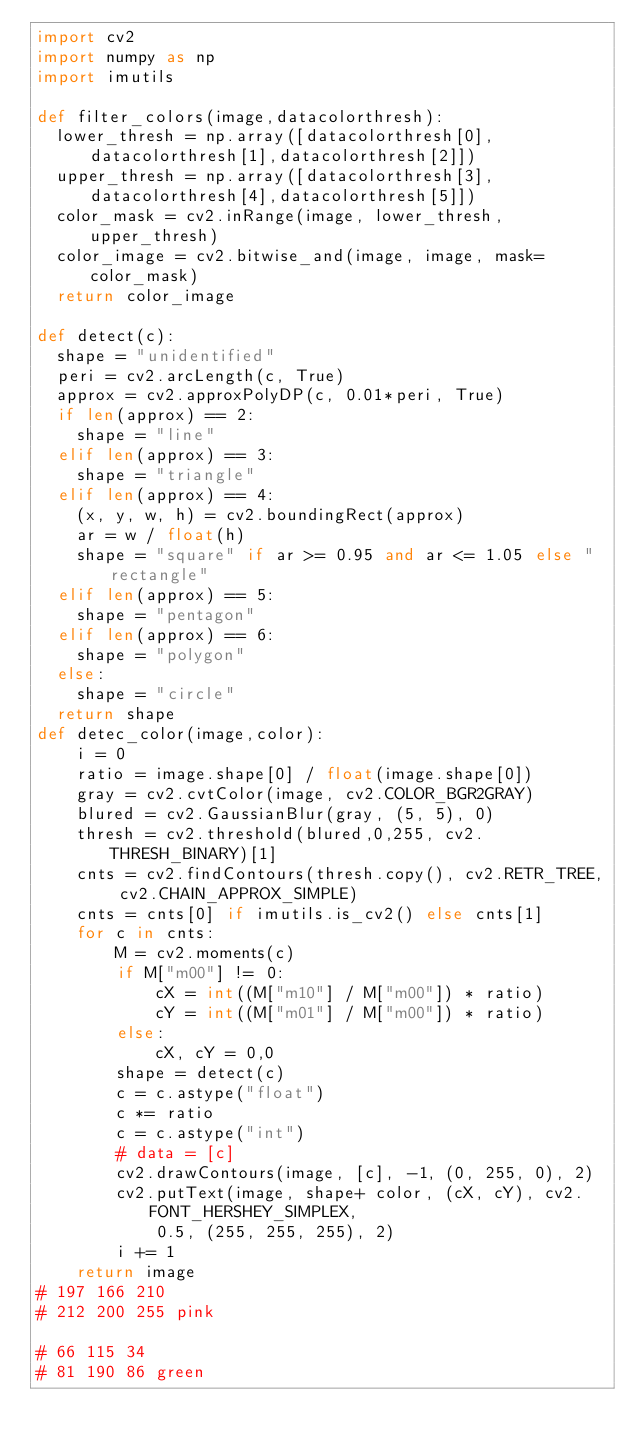Convert code to text. <code><loc_0><loc_0><loc_500><loc_500><_Python_>import cv2
import numpy as np 
import imutils

def filter_colors(image,datacolorthresh):
	lower_thresh = np.array([datacolorthresh[0],datacolorthresh[1],datacolorthresh[2]])
	upper_thresh = np.array([datacolorthresh[3],datacolorthresh[4],datacolorthresh[5]])
	color_mask = cv2.inRange(image, lower_thresh, upper_thresh)
	color_image = cv2.bitwise_and(image, image, mask=color_mask)
	return color_image

def detect(c):
	shape = "unidentified"
	peri = cv2.arcLength(c, True)
	approx = cv2.approxPolyDP(c, 0.01*peri, True)
	if len(approx) == 2:
		shape = "line"
	elif len(approx) == 3:
		shape = "triangle"
	elif len(approx) == 4:
		(x, y, w, h) = cv2.boundingRect(approx)
		ar = w / float(h)
		shape = "square" if ar >= 0.95 and ar <= 1.05 else "rectangle"
	elif len(approx) == 5:
		shape = "pentagon"
	elif len(approx) == 6:
		shape = "polygon"
	else:
		shape = "circle"
	return shape
def detec_color(image,color):
    i = 0
    ratio = image.shape[0] / float(image.shape[0])
    gray = cv2.cvtColor(image, cv2.COLOR_BGR2GRAY)
    blured = cv2.GaussianBlur(gray, (5, 5), 0)
    thresh = cv2.threshold(blured,0,255, cv2.THRESH_BINARY)[1]
    cnts = cv2.findContours(thresh.copy(), cv2.RETR_TREE, cv2.CHAIN_APPROX_SIMPLE)
    cnts = cnts[0] if imutils.is_cv2() else cnts[1]
    for c in cnts:
        M = cv2.moments(c)
        if M["m00"] != 0:
            cX = int((M["m10"] / M["m00"]) * ratio)
            cY = int((M["m01"] / M["m00"]) * ratio)
        else:
            cX, cY = 0,0
        shape = detect(c)
        c = c.astype("float")
        c *= ratio
        c = c.astype("int")
        # data = [c]
        cv2.drawContours(image, [c], -1, (0, 255, 0), 2)
        cv2.putText(image, shape+ color, (cX, cY), cv2.FONT_HERSHEY_SIMPLEX,
            0.5, (255, 255, 255), 2)
        i += 1
    return image
# 197 166 210
# 212 200 255 pink

# 66 115 34
# 81 190 86 green
</code> 